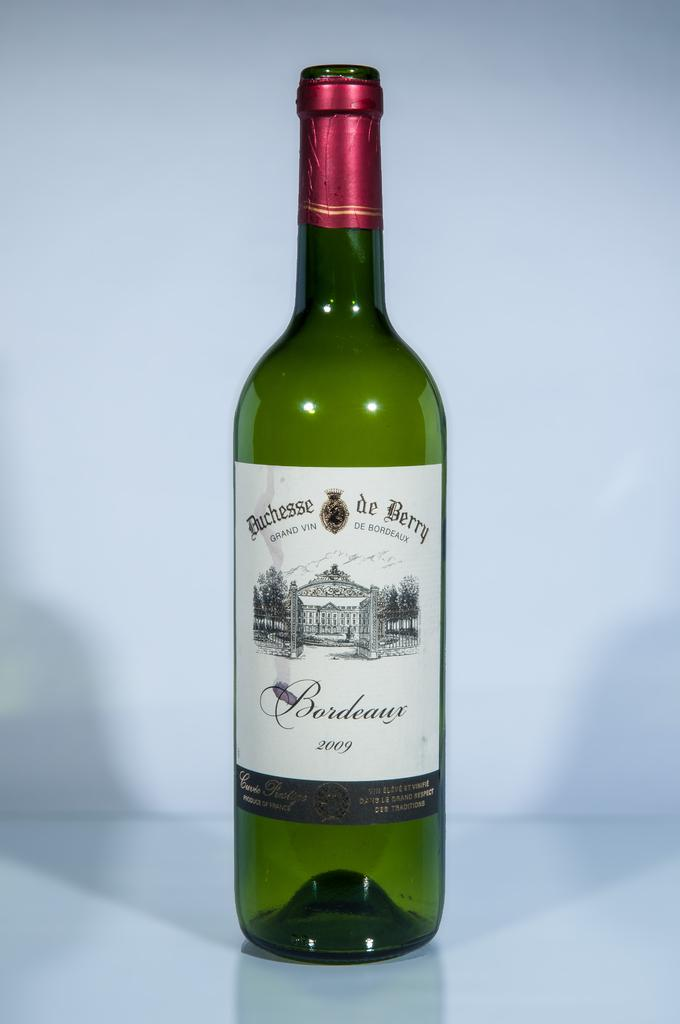<image>
Offer a succinct explanation of the picture presented. A 2009 bottle of Grand Vin De Bordeaux photographed against a white background. 